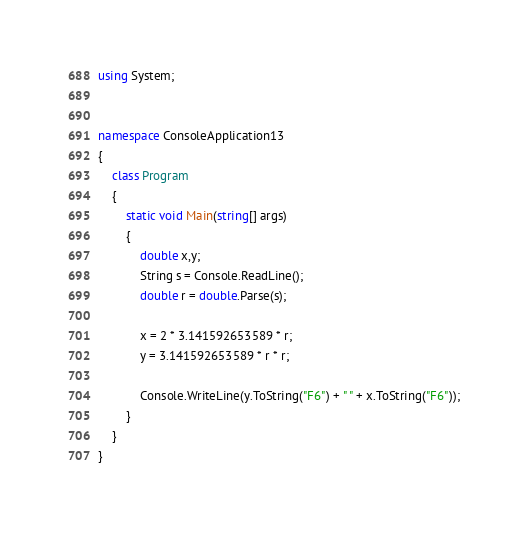Convert code to text. <code><loc_0><loc_0><loc_500><loc_500><_C#_>using System;


namespace ConsoleApplication13
{
    class Program
    {
        static void Main(string[] args)
        {
            double x,y;
            String s = Console.ReadLine();
            double r = double.Parse(s);

            x = 2 * 3.141592653589 * r;
            y = 3.141592653589 * r * r;

            Console.WriteLine(y.ToString("F6") + " " + x.ToString("F6"));
        }
    }
}</code> 